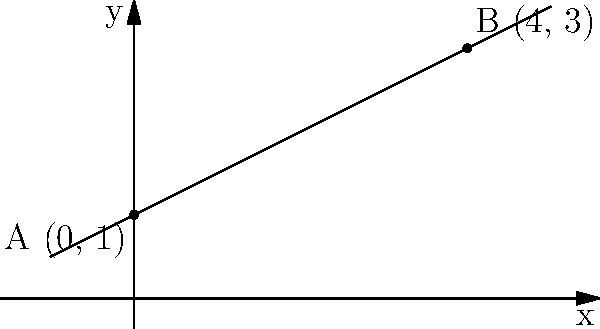During a Civil War campaign, you're tasked with analyzing the terrain for a potential offensive. Two points on the battlefield are marked: Point A (0, 1) and Point B (4, 3), where coordinates represent distance in miles and elevation in hundreds of feet. Calculate the slope of the terrain between these two points. How would this slope impact the movement of troops and artillery? To analyze the steepness of the terrain, we need to calculate the slope between points A and B. Let's follow these steps:

1) Recall the slope formula:
   $$ \text{Slope} = \frac{y_2 - y_1}{x_2 - x_1} $$

2) Identify the coordinates:
   Point A: $(x_1, y_1) = (0, 1)$
   Point B: $(x_2, y_2) = (4, 3)$

3) Plug these values into the slope formula:
   $$ \text{Slope} = \frac{3 - 1}{4 - 0} = \frac{2}{4} = 0.5 $$

4) Interpret the result:
   - The slope is 0.5, which means for every 1 mile of horizontal distance, there's a 0.5 * 100 = 50 feet increase in elevation.
   - This can be expressed as a 1:2 ratio or a 26.6° angle (calculated using $\arctan(0.5)$).

5) Military implications:
   - This moderate slope would present challenges for moving heavy artillery and supply wagons.
   - Infantry would experience some fatigue, but the incline is not severe enough to significantly impede movement.
   - Cavalry charges uphill would be slowed, potentially reducing their effectiveness.
   - Defenders at higher elevations would have a slight advantage in terms of visibility and potential energy for projectiles.

The 0.5 slope indicates a gradual but noticeable incline that would influence military strategy without being a major obstacle.
Answer: Slope = 0.5; moderate incline affecting artillery movement and providing slight defensive advantage to higher positions. 